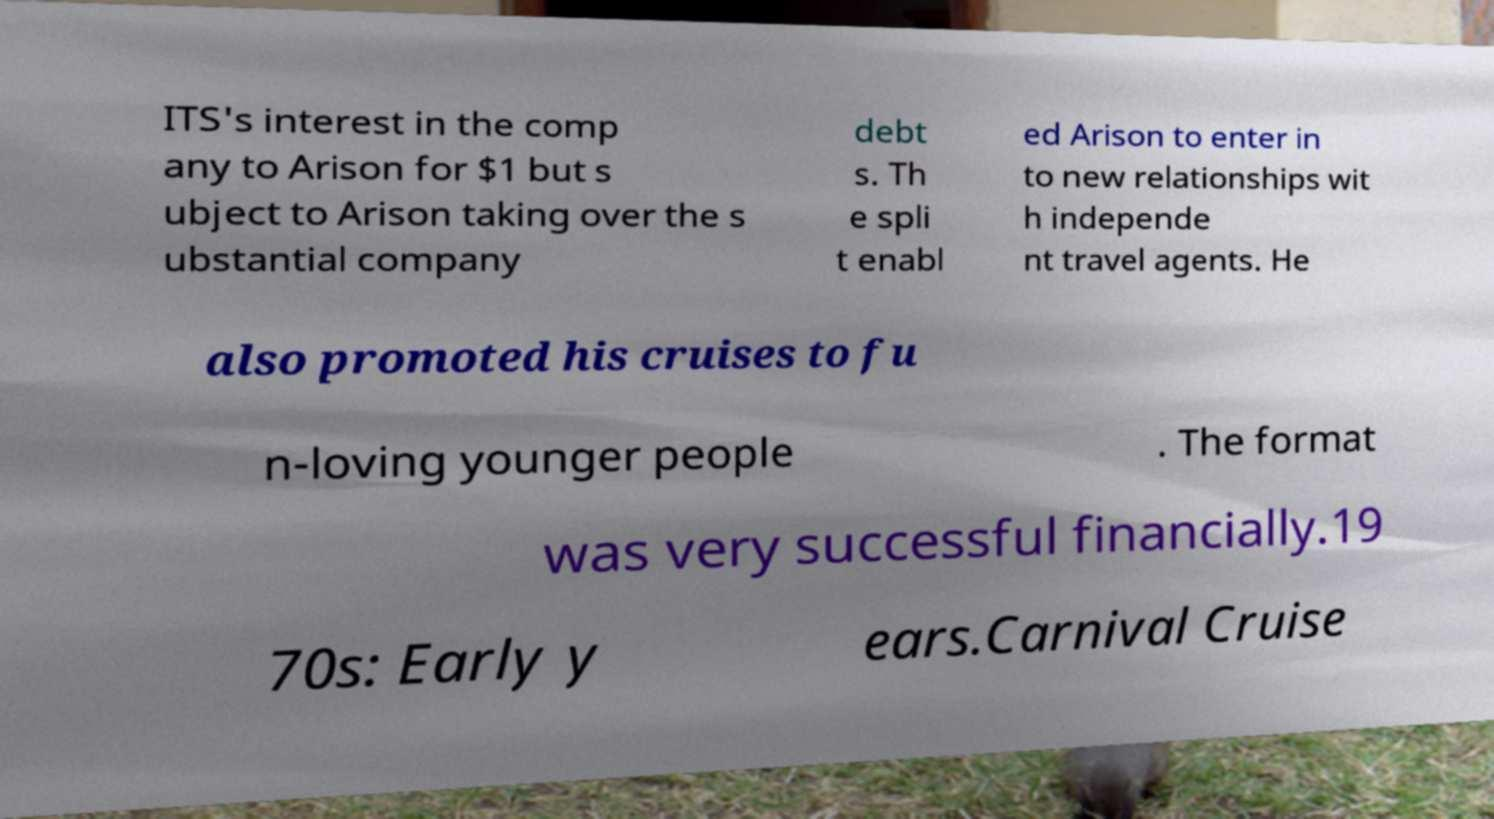Could you assist in decoding the text presented in this image and type it out clearly? ITS's interest in the comp any to Arison for $1 but s ubject to Arison taking over the s ubstantial company debt s. Th e spli t enabl ed Arison to enter in to new relationships wit h independe nt travel agents. He also promoted his cruises to fu n-loving younger people . The format was very successful financially.19 70s: Early y ears.Carnival Cruise 